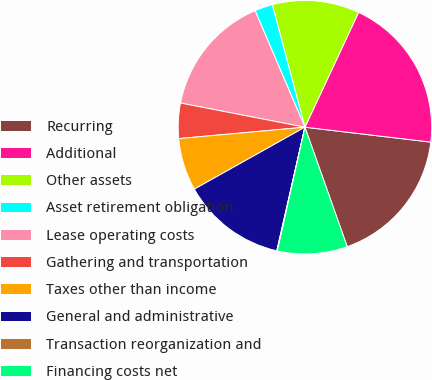Convert chart. <chart><loc_0><loc_0><loc_500><loc_500><pie_chart><fcel>Recurring<fcel>Additional<fcel>Other assets<fcel>Asset retirement obligation<fcel>Lease operating costs<fcel>Gathering and transportation<fcel>Taxes other than income<fcel>General and administrative<fcel>Transaction reorganization and<fcel>Financing costs net<nl><fcel>17.71%<fcel>19.92%<fcel>11.1%<fcel>2.29%<fcel>15.51%<fcel>4.49%<fcel>6.69%<fcel>13.31%<fcel>0.08%<fcel>8.9%<nl></chart> 